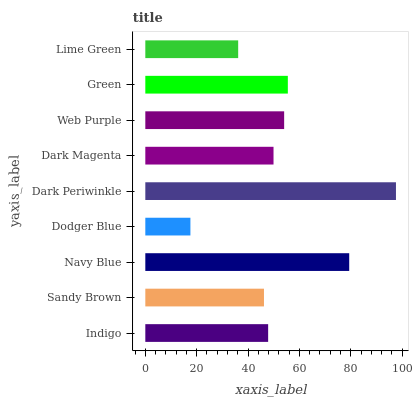Is Dodger Blue the minimum?
Answer yes or no. Yes. Is Dark Periwinkle the maximum?
Answer yes or no. Yes. Is Sandy Brown the minimum?
Answer yes or no. No. Is Sandy Brown the maximum?
Answer yes or no. No. Is Indigo greater than Sandy Brown?
Answer yes or no. Yes. Is Sandy Brown less than Indigo?
Answer yes or no. Yes. Is Sandy Brown greater than Indigo?
Answer yes or no. No. Is Indigo less than Sandy Brown?
Answer yes or no. No. Is Dark Magenta the high median?
Answer yes or no. Yes. Is Dark Magenta the low median?
Answer yes or no. Yes. Is Navy Blue the high median?
Answer yes or no. No. Is Green the low median?
Answer yes or no. No. 